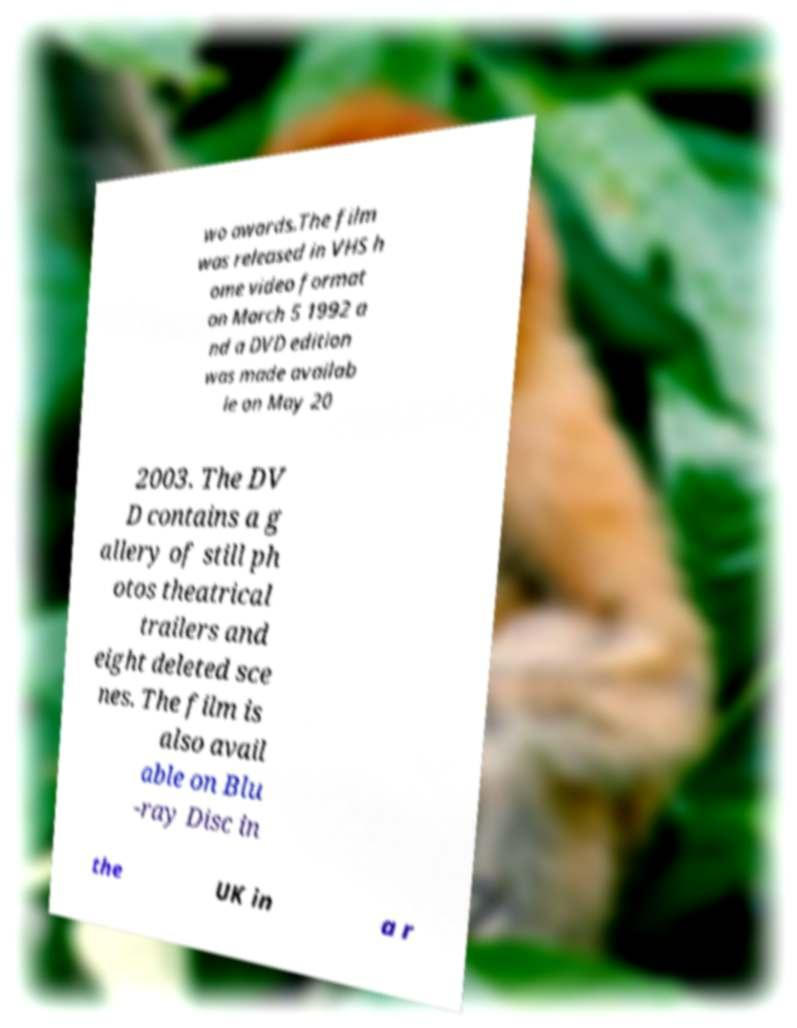For documentation purposes, I need the text within this image transcribed. Could you provide that? wo awards.The film was released in VHS h ome video format on March 5 1992 a nd a DVD edition was made availab le on May 20 2003. The DV D contains a g allery of still ph otos theatrical trailers and eight deleted sce nes. The film is also avail able on Blu -ray Disc in the UK in a r 